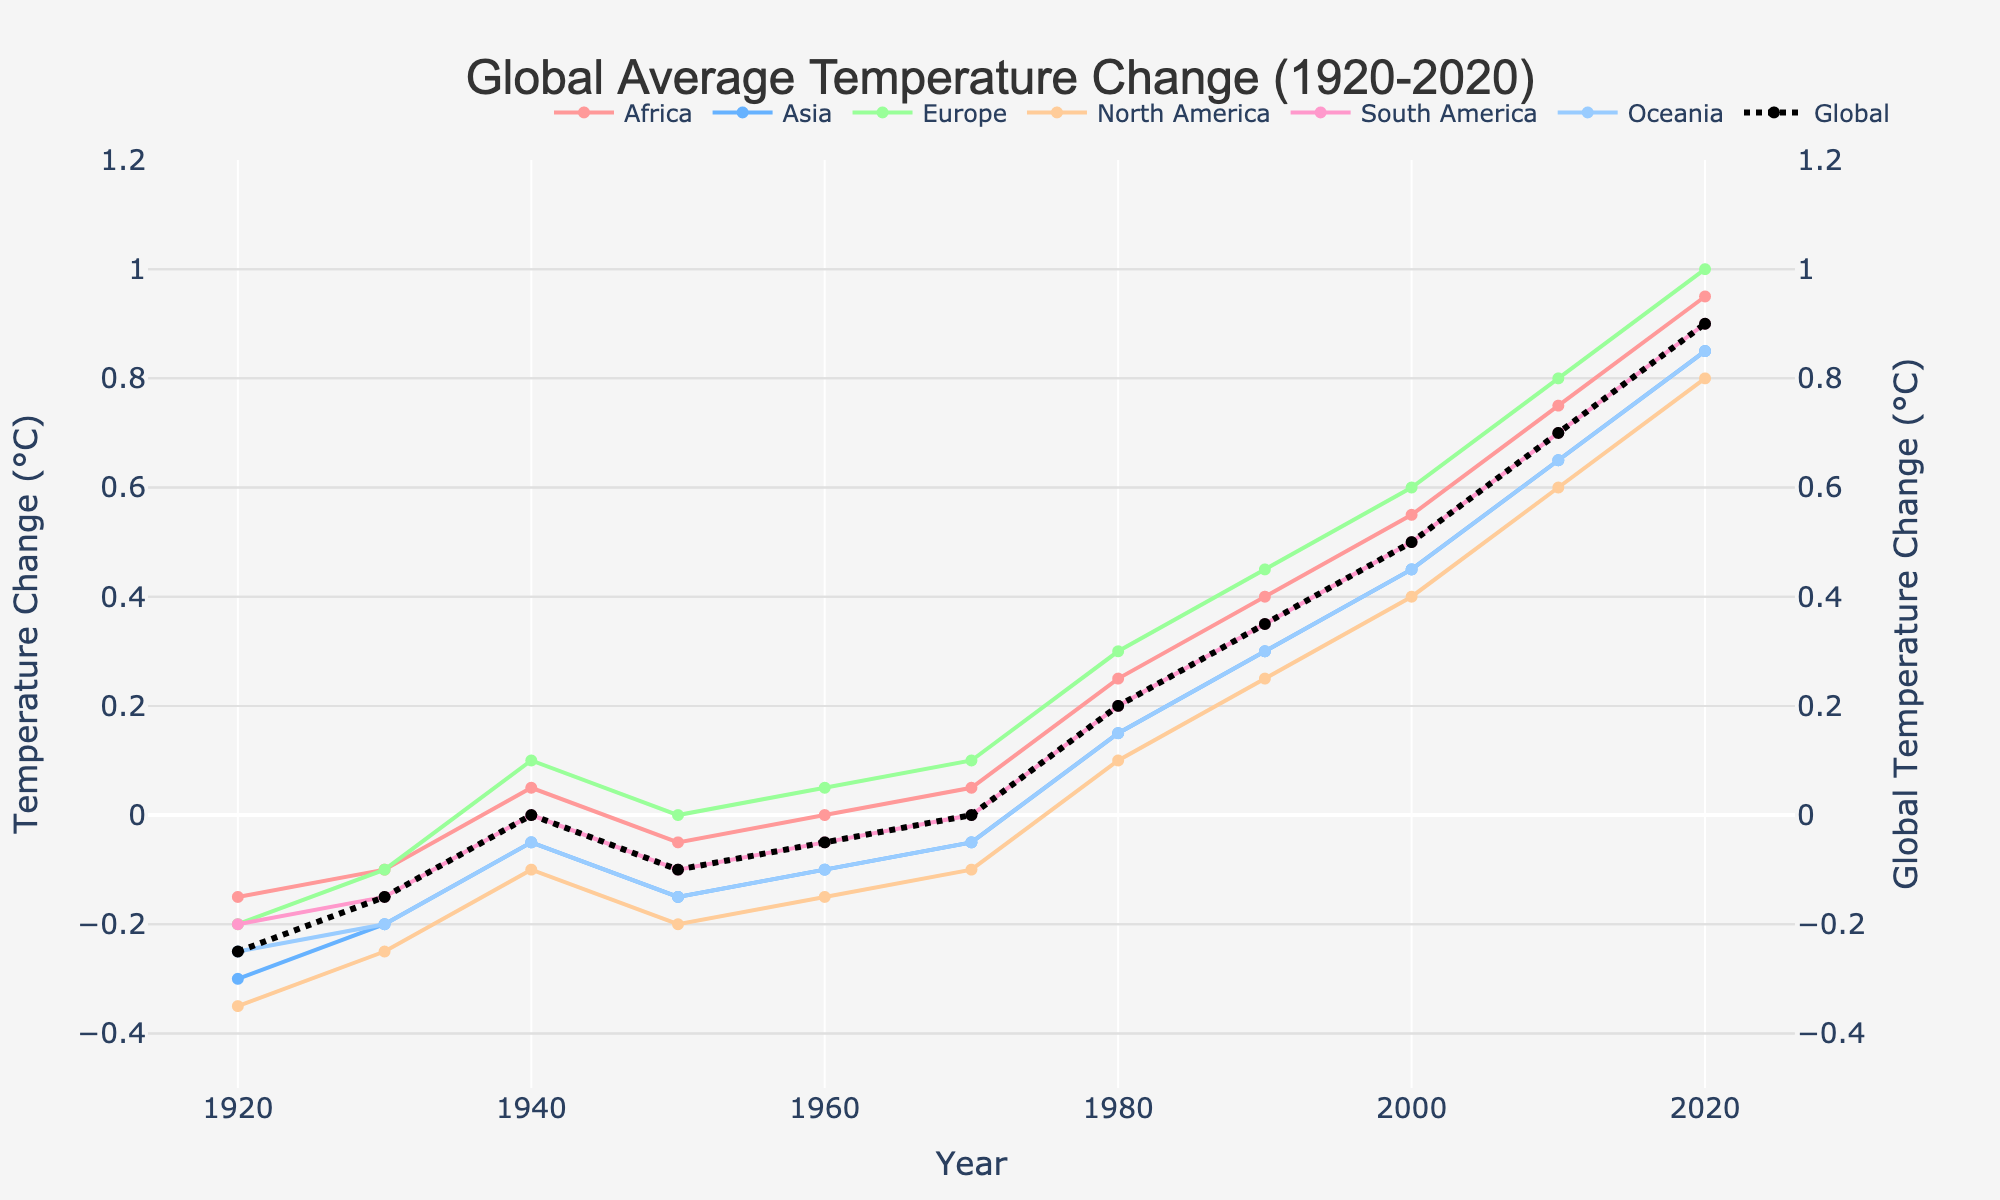Which continent experienced the highest temperature change in 2020? Check the line corresponding to the year 2020 for each continent and identify the highest value.
Answer: Europe Which continent has the least degree of temperature change throughout the observed period? Track the line for each continent from 1920 to 2020 and see which line has the smallest fluctuations.
Answer: Oceania Which year did Europe surpass the global average temperature change? Compare the line for Europe with the global line and identify the first year Europe's line is above the global line.
Answer: 1960 Compare the temperature change in North America and South America in 1980. Which one was higher and by how much? Find the points for North America and South America in 1980, then subtract the value for South America from the value for North America.
Answer: North America by 0.10°C Was the temperature change in Asia and Africa equal at any point from 1920 to 2020? Look at the lines for Asia and Africa and check if they intersect at any point between 1920 and 2020.
Answer: No By how much did the global temperature change differ between 2000 and 2020? Subtract the global temperature change in 2000 from that in 2020.
Answer: 0.40°C What is the average temperature change in Africa over the decades observed? Add the temperature changes for Africa from each decade and divide by the number of data points (10).
Answer: 0.325°C Which continent had the most consistent temperature increase over the observed period? Compare the lines of all continents and see which one displays the most linear increase.
Answer: Europe In 1940, which continent had a positive temperature change? Look at the value points for each continent in the year 1940 and determine which are above 0.
Answer: Africa Compare the temperature changes for Africa and Oceania in the year 1960. By how much did they differ, and which was higher? Locate the points for Africa and Oceania in 1960, then subtract the value for Oceania from the value for Africa to find the difference.
Answer: Africa by 0.10°C 